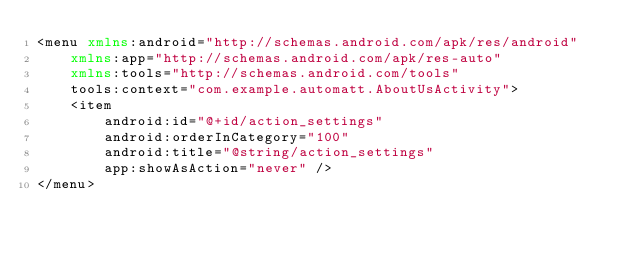Convert code to text. <code><loc_0><loc_0><loc_500><loc_500><_XML_><menu xmlns:android="http://schemas.android.com/apk/res/android"
    xmlns:app="http://schemas.android.com/apk/res-auto"
    xmlns:tools="http://schemas.android.com/tools"
    tools:context="com.example.automatt.AboutUsActivity">
    <item
        android:id="@+id/action_settings"
        android:orderInCategory="100"
        android:title="@string/action_settings"
        app:showAsAction="never" />
</menu></code> 